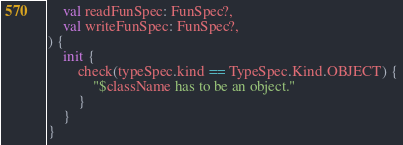<code> <loc_0><loc_0><loc_500><loc_500><_Kotlin_>    val readFunSpec: FunSpec?,
    val writeFunSpec: FunSpec?,
) {
    init {
        check(typeSpec.kind == TypeSpec.Kind.OBJECT) {
            "$className has to be an object."
        }
    }
}
</code> 